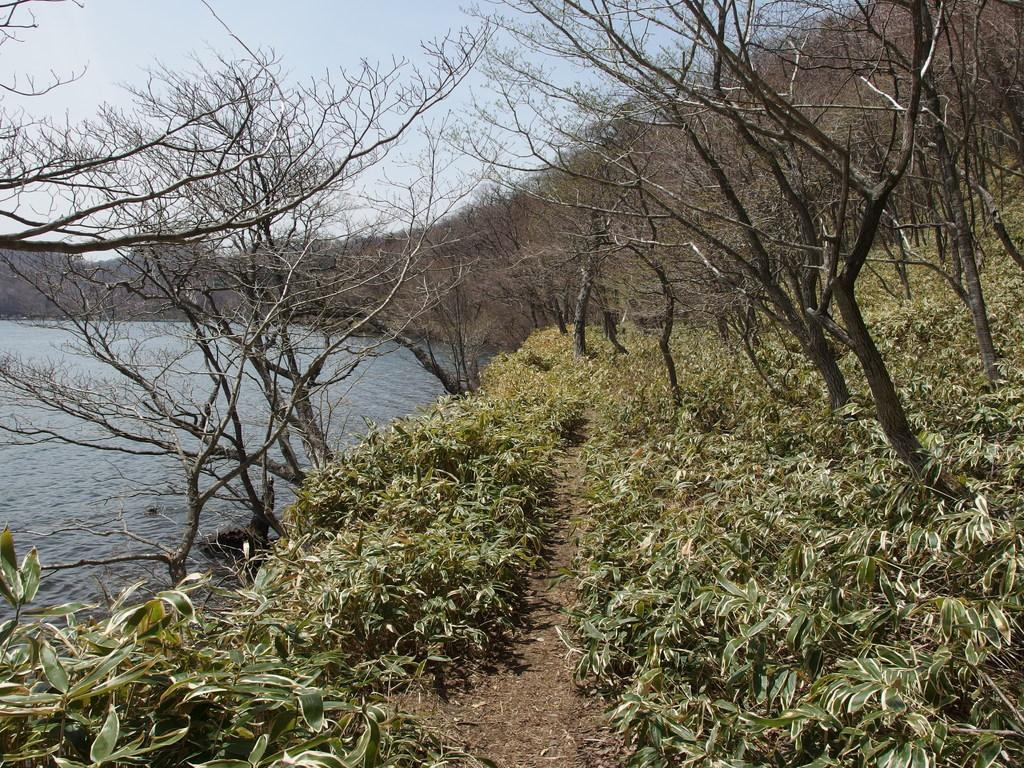What is the main feature of the image? There is a path or way in the image. What can be seen on either side of the path? There are plants and dried trees on either side of the path. Is there any water visible in the image? Yes, there is water visible in the left corner of the image. Can you tell me how many tramps are sitting on the path in the image? There are no tramps present in the image. What is the relationship between the plants and the sister in the image? There is no mention of a sister in the image; it only features a path, plants, dried trees, and water. 